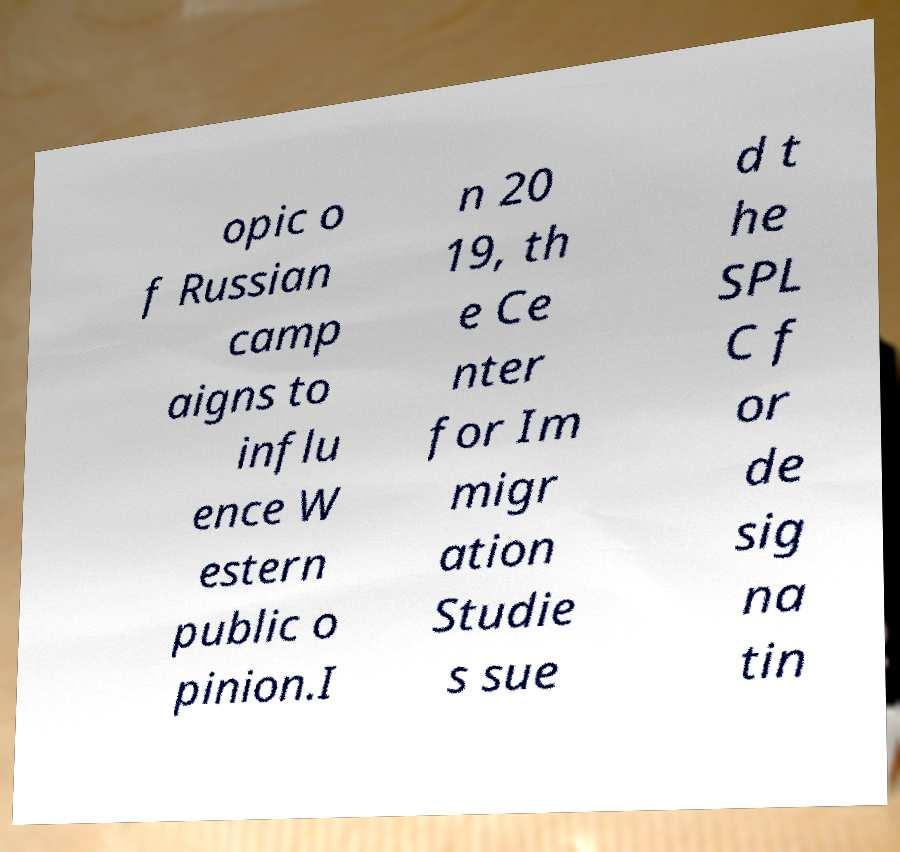Could you assist in decoding the text presented in this image and type it out clearly? opic o f Russian camp aigns to influ ence W estern public o pinion.I n 20 19, th e Ce nter for Im migr ation Studie s sue d t he SPL C f or de sig na tin 